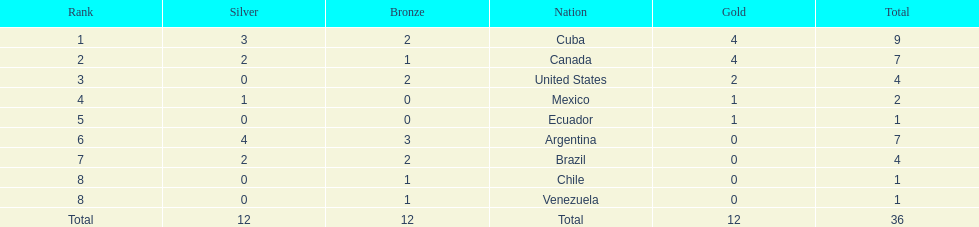Which country won the largest haul of bronze medals? Argentina. 